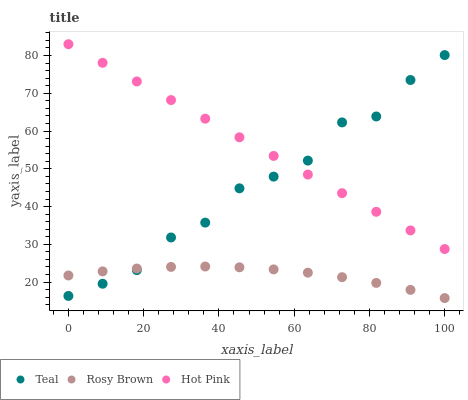Does Rosy Brown have the minimum area under the curve?
Answer yes or no. Yes. Does Hot Pink have the maximum area under the curve?
Answer yes or no. Yes. Does Teal have the minimum area under the curve?
Answer yes or no. No. Does Teal have the maximum area under the curve?
Answer yes or no. No. Is Hot Pink the smoothest?
Answer yes or no. Yes. Is Teal the roughest?
Answer yes or no. Yes. Is Teal the smoothest?
Answer yes or no. No. Is Hot Pink the roughest?
Answer yes or no. No. Does Rosy Brown have the lowest value?
Answer yes or no. Yes. Does Teal have the lowest value?
Answer yes or no. No. Does Hot Pink have the highest value?
Answer yes or no. Yes. Does Teal have the highest value?
Answer yes or no. No. Is Rosy Brown less than Hot Pink?
Answer yes or no. Yes. Is Hot Pink greater than Rosy Brown?
Answer yes or no. Yes. Does Rosy Brown intersect Teal?
Answer yes or no. Yes. Is Rosy Brown less than Teal?
Answer yes or no. No. Is Rosy Brown greater than Teal?
Answer yes or no. No. Does Rosy Brown intersect Hot Pink?
Answer yes or no. No. 